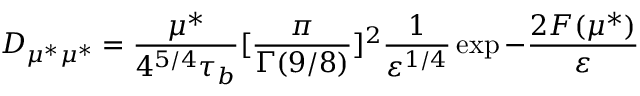Convert formula to latex. <formula><loc_0><loc_0><loc_500><loc_500>D _ { \mu ^ { * } \mu ^ { * } } = \frac { \mu ^ { * } } { 4 ^ { 5 / 4 } \tau _ { b } } [ \frac { \pi } { \Gamma ( 9 / 8 ) } ] ^ { 2 } \frac { 1 } { \varepsilon ^ { 1 / 4 } } \exp - \frac { 2 F ( \mu ^ { * } ) } { \varepsilon }</formula> 